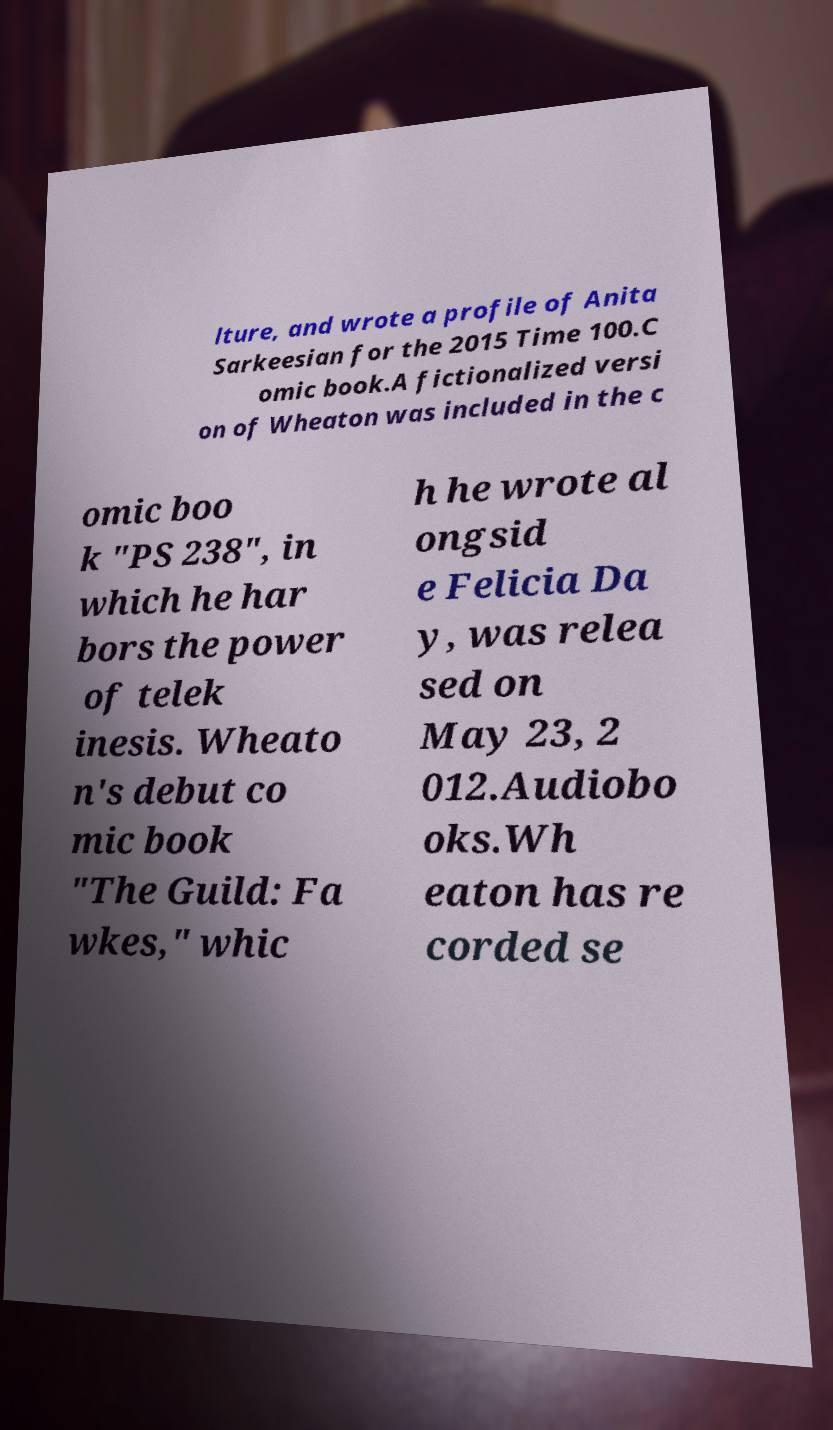Please identify and transcribe the text found in this image. lture, and wrote a profile of Anita Sarkeesian for the 2015 Time 100.C omic book.A fictionalized versi on of Wheaton was included in the c omic boo k "PS 238", in which he har bors the power of telek inesis. Wheato n's debut co mic book "The Guild: Fa wkes," whic h he wrote al ongsid e Felicia Da y, was relea sed on May 23, 2 012.Audiobo oks.Wh eaton has re corded se 